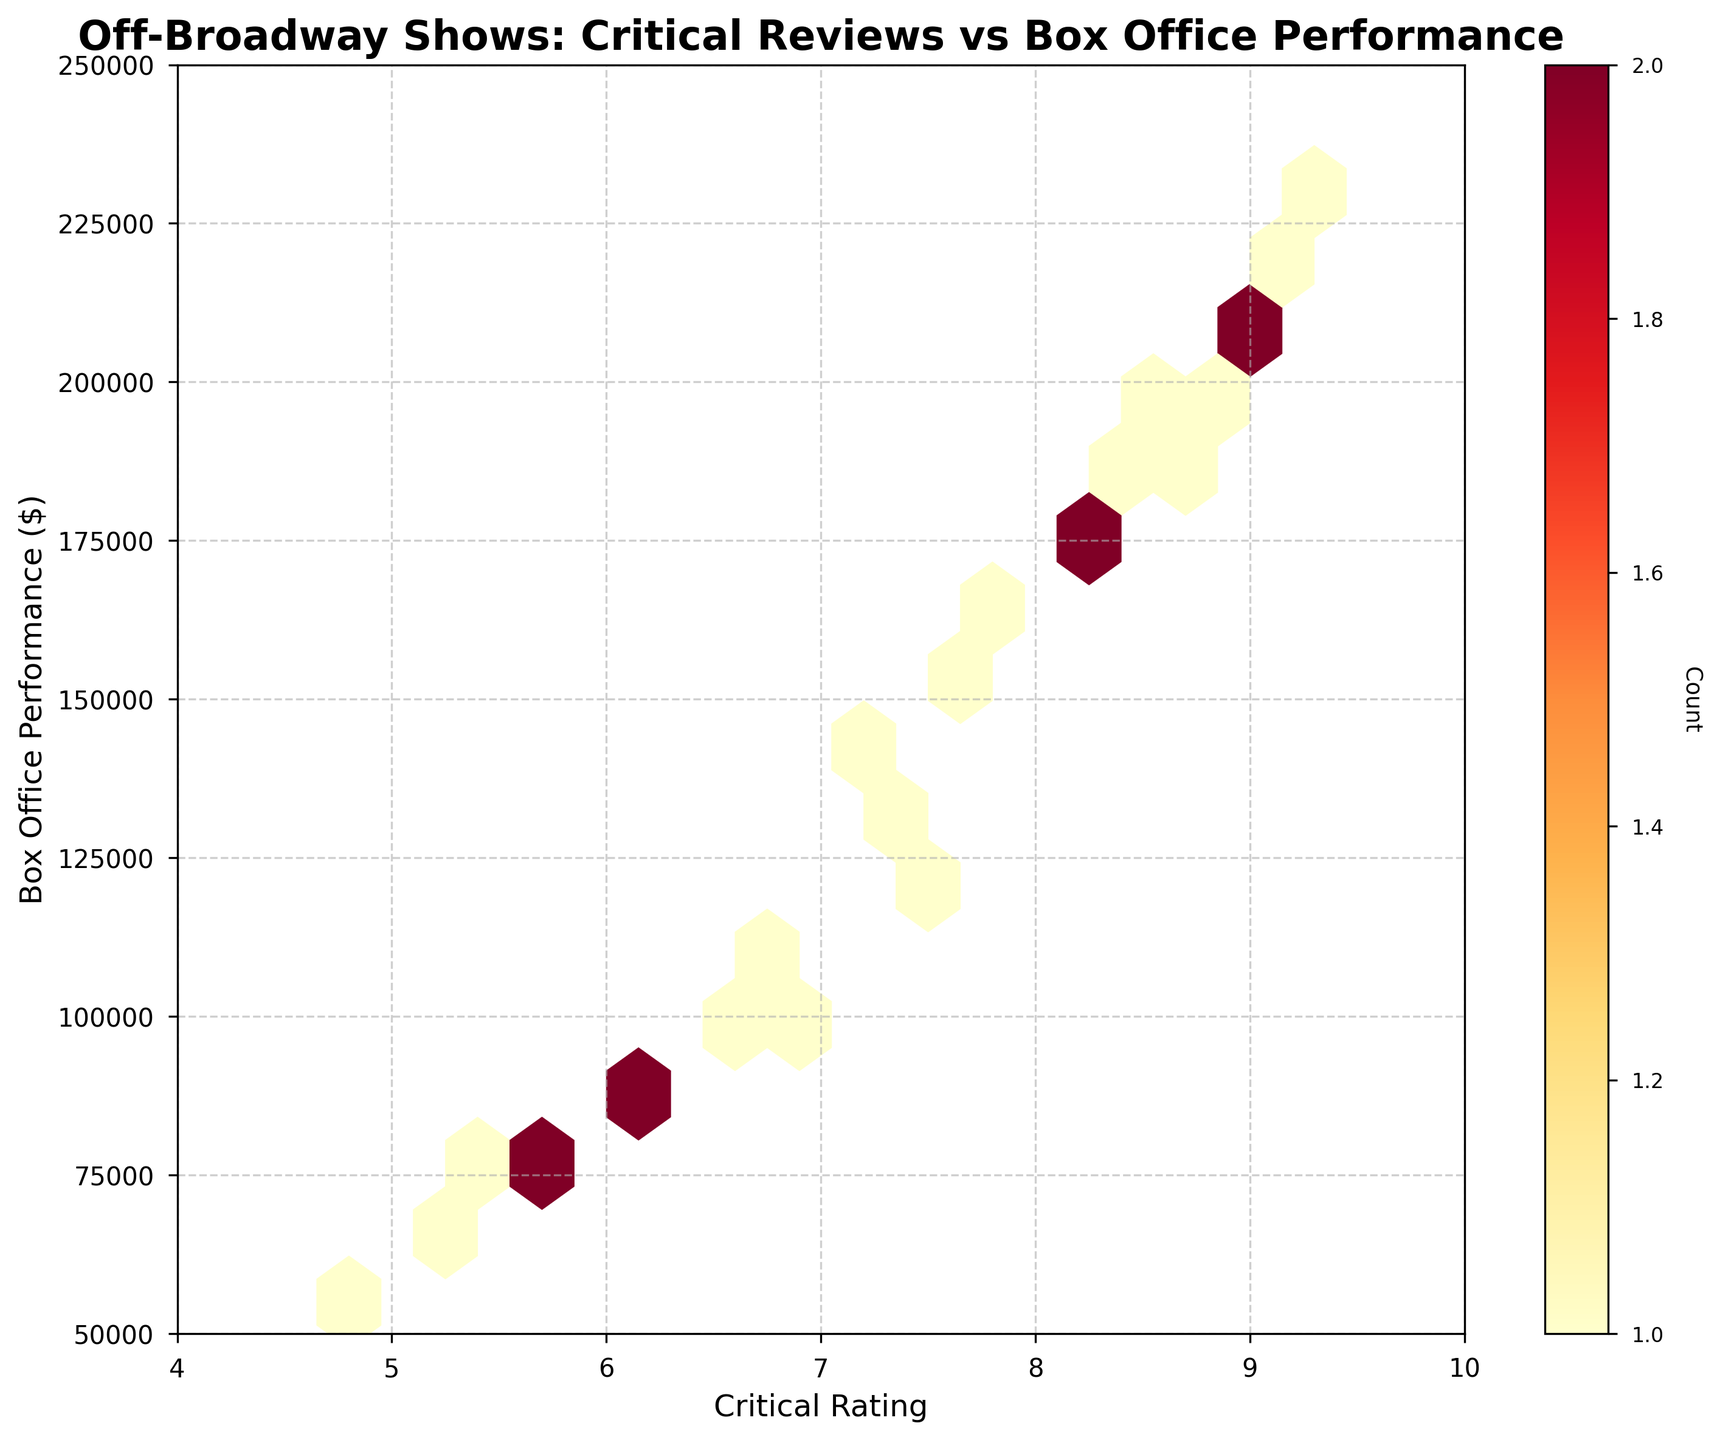What is the title of the chart? The title is often located at the top of the chart and typically provides a summary of what the data represents. In this case, the title "Off-Broadway Shows: Critical Reviews vs Box Office Performance" is displayed prominently at the top.
Answer: Off-Broadway Shows: Critical Reviews vs Box Office Performance What do the x and y axes represent? The labels on the x and y axes provide information about what each axis represents. Here, the x-axis is labeled "Critical Rating" and the y-axis is labeled "Box Office Performance ($)".
Answer: Critical Rating and Box Office Performance ($) What is the range of Box Office Performance shown on the y-axis? The y-axis shows the range of box office earnings which starts at 50,000 and goes up to 250,000. This can be seen from the numerical markings on the y-axis.
Answer: 50,000 to 250,000 What does the color intensity in the hexbin plot signify? In hexbin plots, color intensity usually represents the density of data points within each hexbin. In this plot, the color bar indicates that darker colors denote a higher count of shows in that range.
Answer: Count of shows Which box office performance range has the highest number of shows with critical ratings between 8.5 and 9.0? By looking at the densest areas on the plot around critical ratings between 8.5 and 9.0, it appears that the range of box office performance from approximately $180,000 to $230,000 has the highest density.
Answer: $180,000 to $230,000 What is the critical rating range with the least data points? Observing the dispersion of color density on the plot, the critical rating range around 4 to 5.5 appears to have the least data points as indicated by lighter or missing hexagons.
Answer: 4 to 5.5 Are there more shows with a box office performance above or below $150,000? To determine this, we can compare the density of hexagons above and below the $150,000 mark on the y-axis. There is a higher density of data points above $150,000.
Answer: Above $150,000 Is there a general trend between the Critical Rating and Box Office Performance? Analyzing a hexbin plot can reveal trends between variables. Here, we see that as critical ratings increase, there tends to be higher box office performance, indicated by the grouping of dense hexagons moving upwards as ratings increase.
Answer: Yes, higher critical ratings generally correspond to higher box office performance Which critical rating has the maximum box office performance, based on the densest hexbin? The hexbin with the highest box office performance falls within the critical rating range of approximately 9.1 to 9.3. The densest hexbin at the top indicates box office performance around $230,000.
Answer: 9.1 to 9.3 How does the color bar enhance your understanding of the data distribution? The color bar on the right of the plot indicates the count of data points within each hexbin. This helps in understanding not just where individual points lie, but also where clusters of data points are heavily concentrated, providing insights into densely populated ranges.
Answer: It shows the count of data points within each hexbin, indicating density 